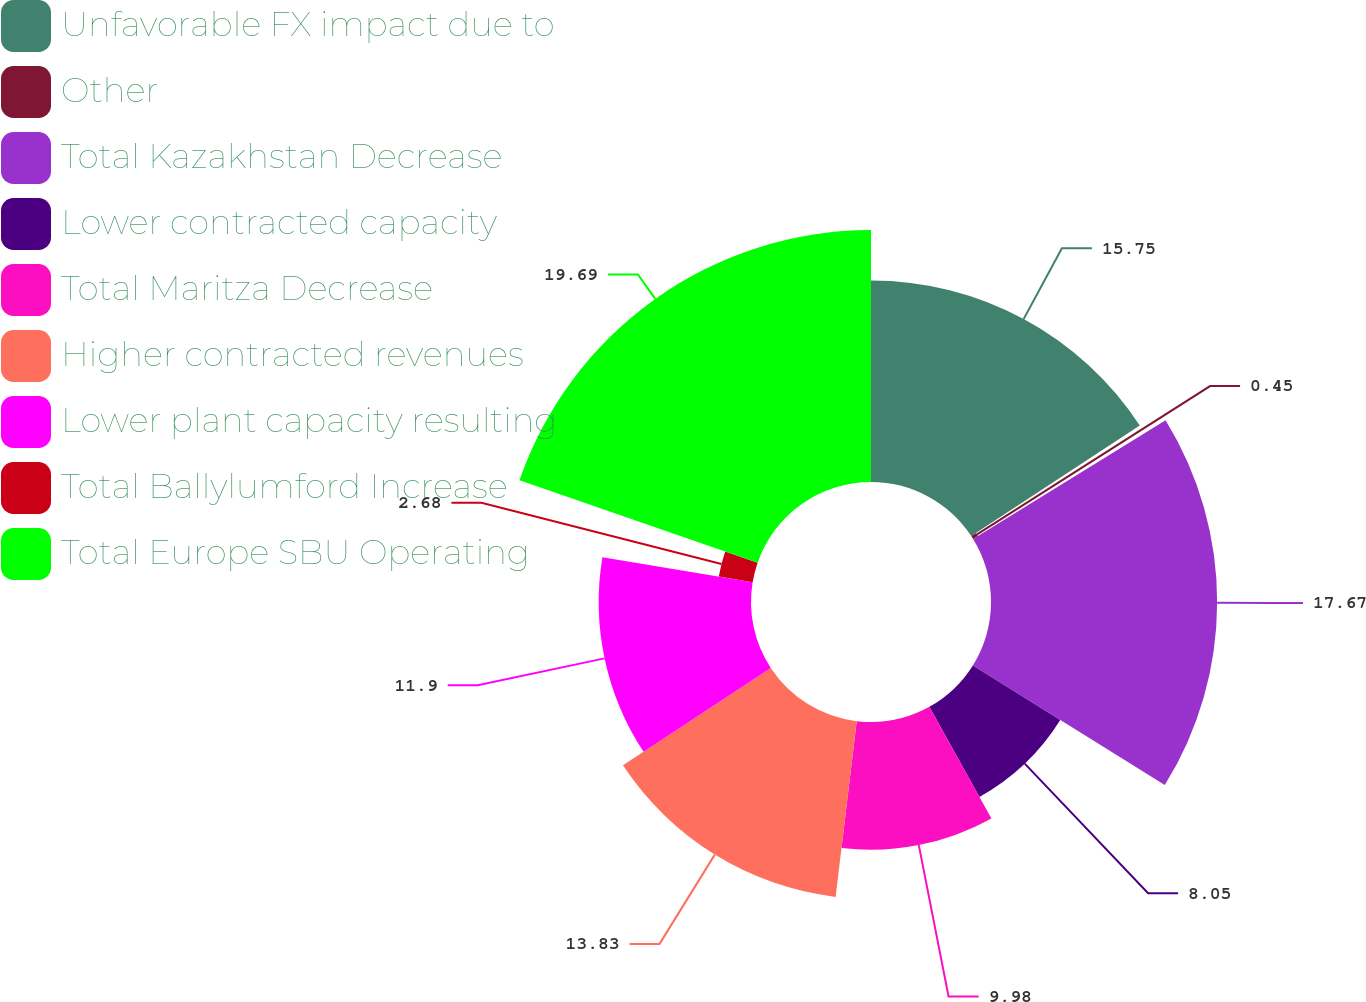Convert chart to OTSL. <chart><loc_0><loc_0><loc_500><loc_500><pie_chart><fcel>Unfavorable FX impact due to<fcel>Other<fcel>Total Kazakhstan Decrease<fcel>Lower contracted capacity<fcel>Total Maritza Decrease<fcel>Higher contracted revenues<fcel>Lower plant capacity resulting<fcel>Total Ballylumford Increase<fcel>Total Europe SBU Operating<nl><fcel>15.75%<fcel>0.45%<fcel>17.67%<fcel>8.05%<fcel>9.98%<fcel>13.83%<fcel>11.9%<fcel>2.68%<fcel>19.69%<nl></chart> 